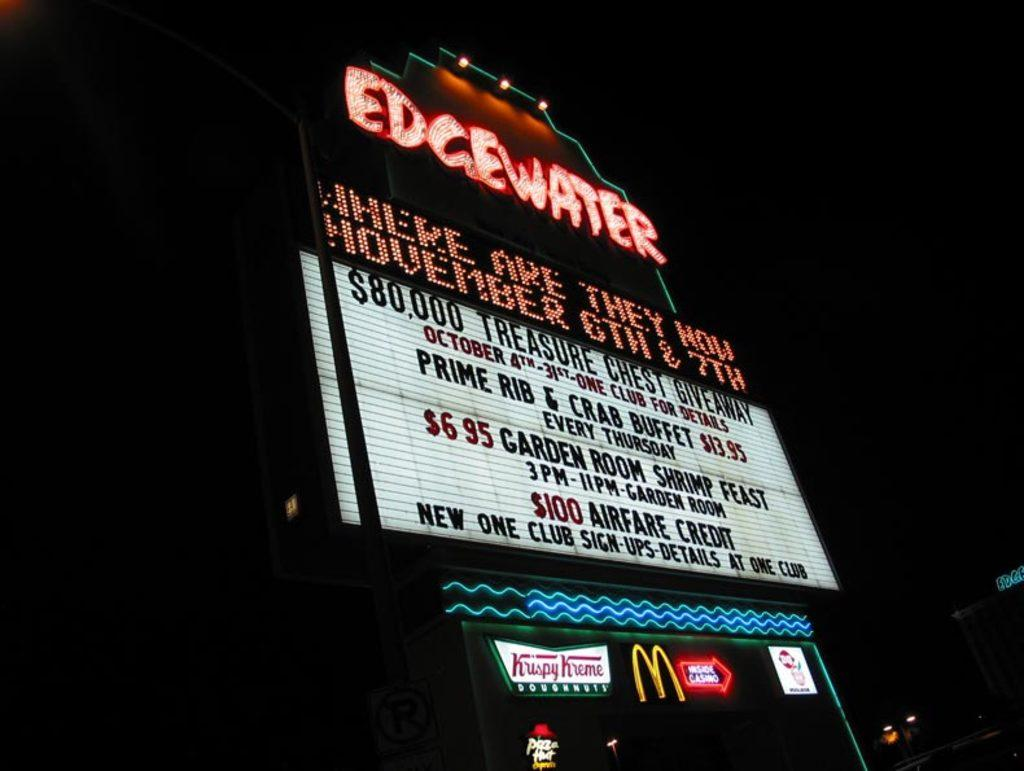Provide a one-sentence caption for the provided image. A neon sign at night advertises the Edgewater Bar and function room. 